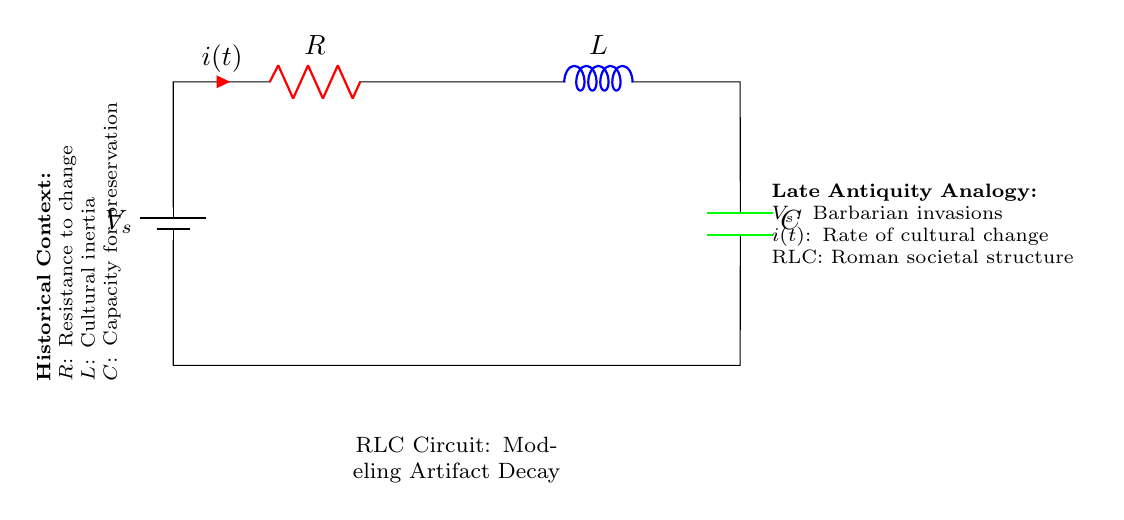What is the voltage source represented in the circuit? The voltage source in the circuit is labeled as \(V_s\), which symbolizes an external influence, akin to barbarian invasions in historical context.
Answer: \(V_s\) What is the role of the resistor in this circuit? The resistor, labeled \(R\), represents the resistance to change in the decay of artifacts, analogous to societal resistance to external influences.
Answer: Resistance to change What does the inductor represent in the context of the circuit? The inductor, labeled \(L\), represents cultural inertia, indicating how slowly society adapts to changes over time, as it stores energy.
Answer: Cultural inertia What is the relationship between current and time in this circuit? The current, denoted as \(i(t)\), signifies the rate of cultural change over time, showing how quickly change happens in response to external pressures.
Answer: Rate of cultural change How does the capacitor function in the context of preservation? The capacitor, labeled \(C\), symbolizes the capacity for preservation, as it holds and manages the charge, similar to how a culture preserves its artifacts against decay.
Answer: Capacity for preservation What do the colors of the components signify in this circuit? The colors differentiate the components: red for resistance, blue for inductance, and green for capacitance, offering a clear visual distinction of each component's role in the circuit.
Answer: Resistance: red, Inductance: blue, Capacitance: green What would happen if the resistance is increased in this circuit? Increasing the resistance \(R\) would slow down the overall decay process of artifacts, symbolizing a stronger resistance to change, thus affecting the current \(i(t)\) that represents cultural change.
Answer: Slower decay process 